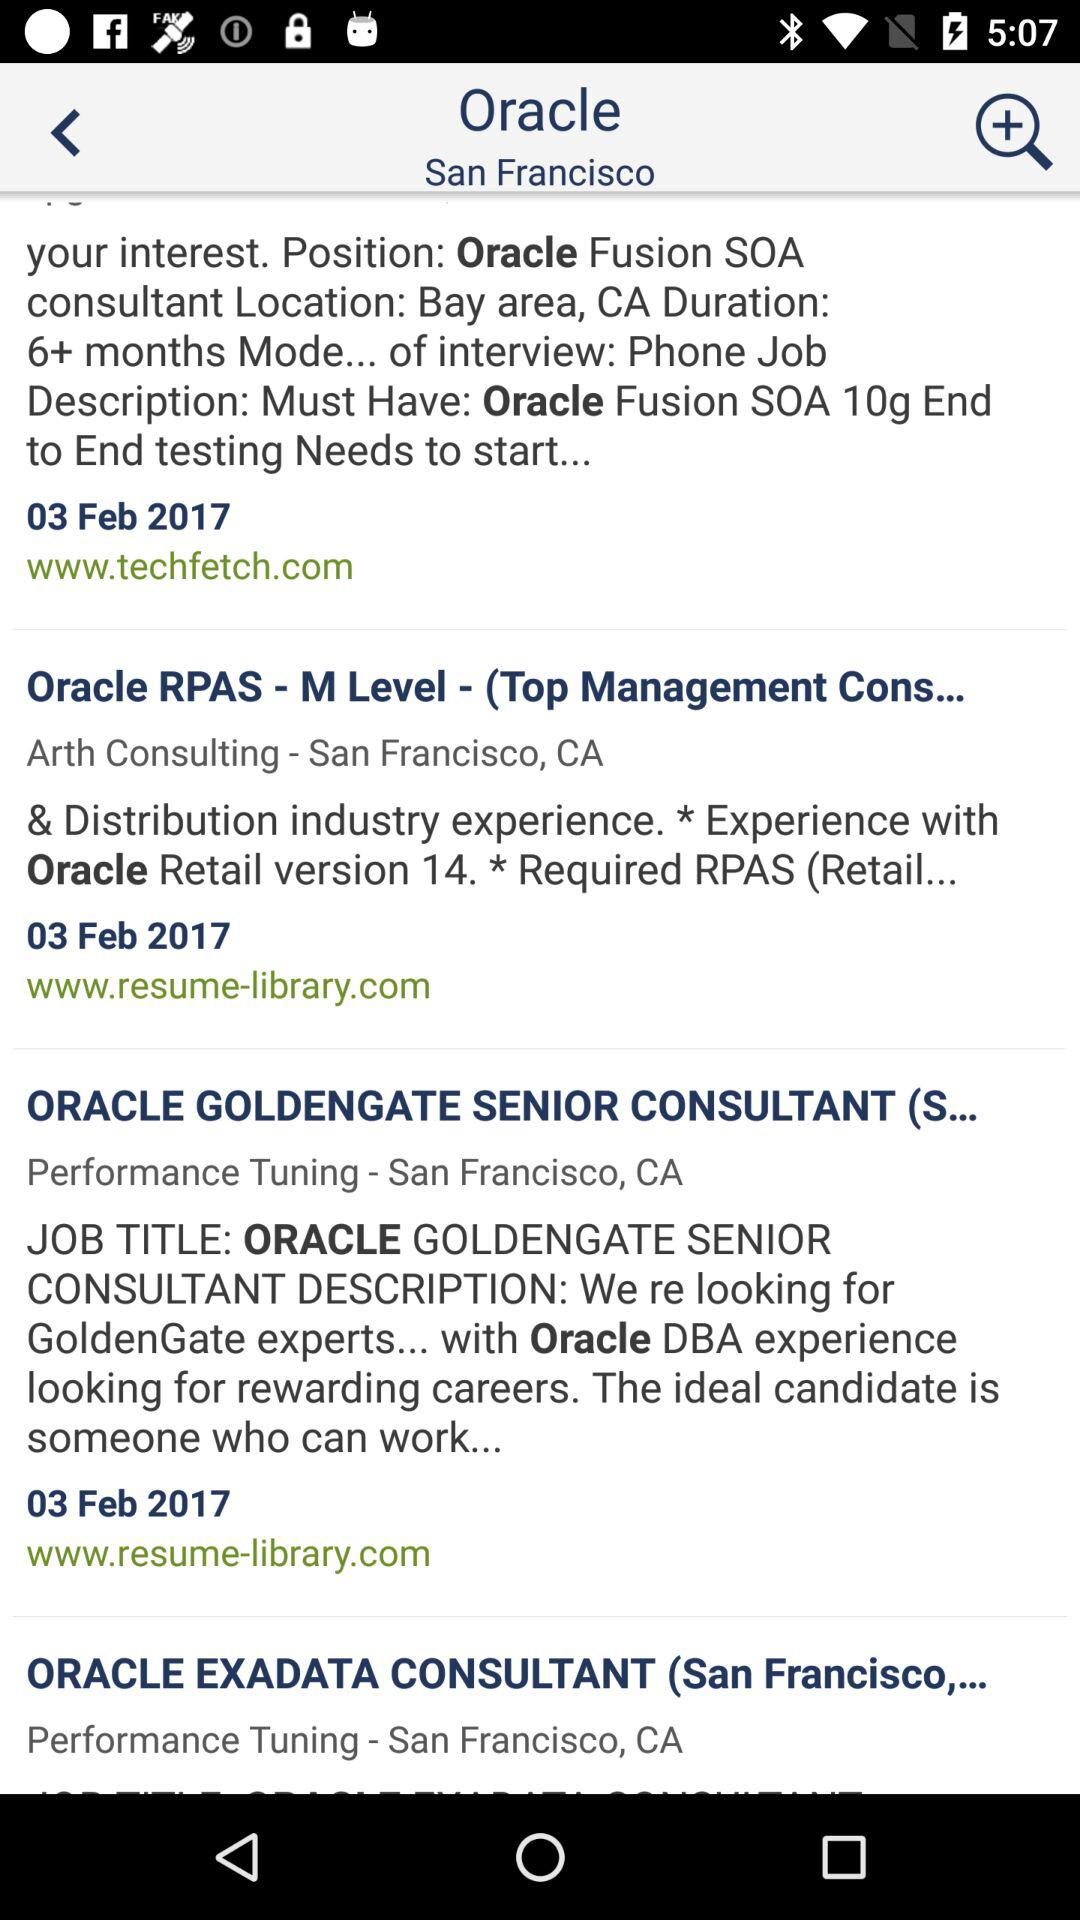What is the mode of interview for the position of "Oracle" fusion SOA consultant? The mode of interview for the position of "Oracle" fusion SOA consultant is by phone. 